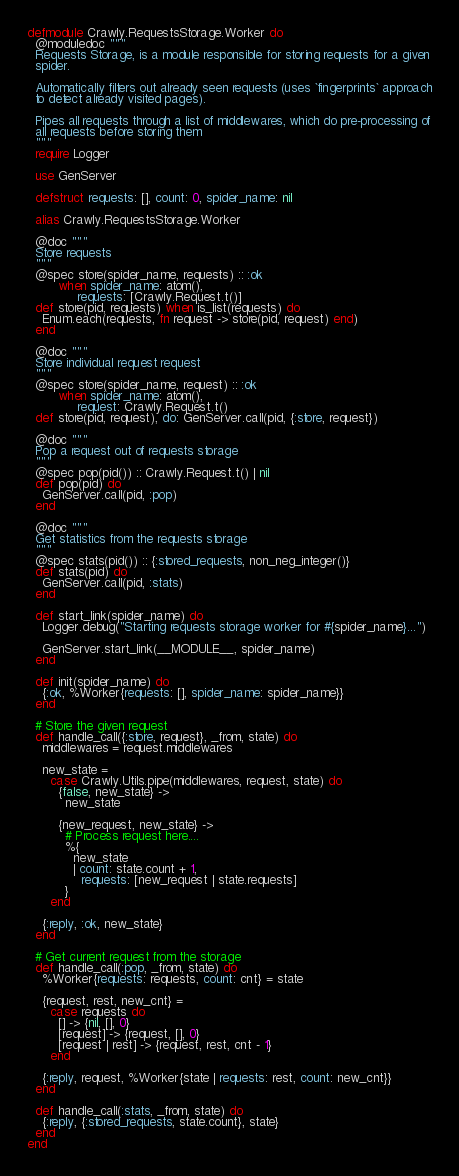Convert code to text. <code><loc_0><loc_0><loc_500><loc_500><_Elixir_>defmodule Crawly.RequestsStorage.Worker do
  @moduledoc """
  Requests Storage, is a module responsible for storing requests for a given
  spider.

  Automatically filters out already seen requests (uses `fingerprints` approach
  to detect already visited pages).

  Pipes all requests through a list of middlewares, which do pre-processing of
  all requests before storing them
  """
  require Logger

  use GenServer

  defstruct requests: [], count: 0, spider_name: nil

  alias Crawly.RequestsStorage.Worker

  @doc """
  Store requests
  """
  @spec store(spider_name, requests) :: :ok
        when spider_name: atom(),
             requests: [Crawly.Request.t()]
  def store(pid, requests) when is_list(requests) do
    Enum.each(requests, fn request -> store(pid, request) end)
  end

  @doc """
  Store individual request request
  """
  @spec store(spider_name, request) :: :ok
        when spider_name: atom(),
             request: Crawly.Request.t()
  def store(pid, request), do: GenServer.call(pid, {:store, request})

  @doc """
  Pop a request out of requests storage
  """
  @spec pop(pid()) :: Crawly.Request.t() | nil
  def pop(pid) do
    GenServer.call(pid, :pop)
  end

  @doc """
  Get statistics from the requests storage
  """
  @spec stats(pid()) :: {:stored_requests, non_neg_integer()}
  def stats(pid) do
    GenServer.call(pid, :stats)
  end

  def start_link(spider_name) do
    Logger.debug("Starting requests storage worker for #{spider_name}...")

    GenServer.start_link(__MODULE__, spider_name)
  end

  def init(spider_name) do
    {:ok, %Worker{requests: [], spider_name: spider_name}}
  end

  # Store the given request
  def handle_call({:store, request}, _from, state) do
    middlewares = request.middlewares

    new_state =
      case Crawly.Utils.pipe(middlewares, request, state) do
        {false, new_state} ->
          new_state

        {new_request, new_state} ->
          # Process request here....
          %{
            new_state
            | count: state.count + 1,
              requests: [new_request | state.requests]
          }
      end

    {:reply, :ok, new_state}
  end

  # Get current request from the storage
  def handle_call(:pop, _from, state) do
    %Worker{requests: requests, count: cnt} = state

    {request, rest, new_cnt} =
      case requests do
        [] -> {nil, [], 0}
        [request] -> {request, [], 0}
        [request | rest] -> {request, rest, cnt - 1}
      end

    {:reply, request, %Worker{state | requests: rest, count: new_cnt}}
  end

  def handle_call(:stats, _from, state) do
    {:reply, {:stored_requests, state.count}, state}
  end
end
</code> 